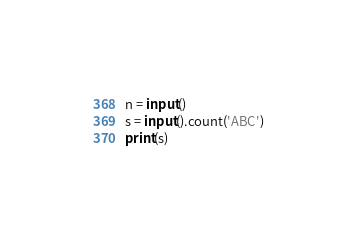<code> <loc_0><loc_0><loc_500><loc_500><_Python_>n = input()
s = input().count('ABC')
print(s)</code> 